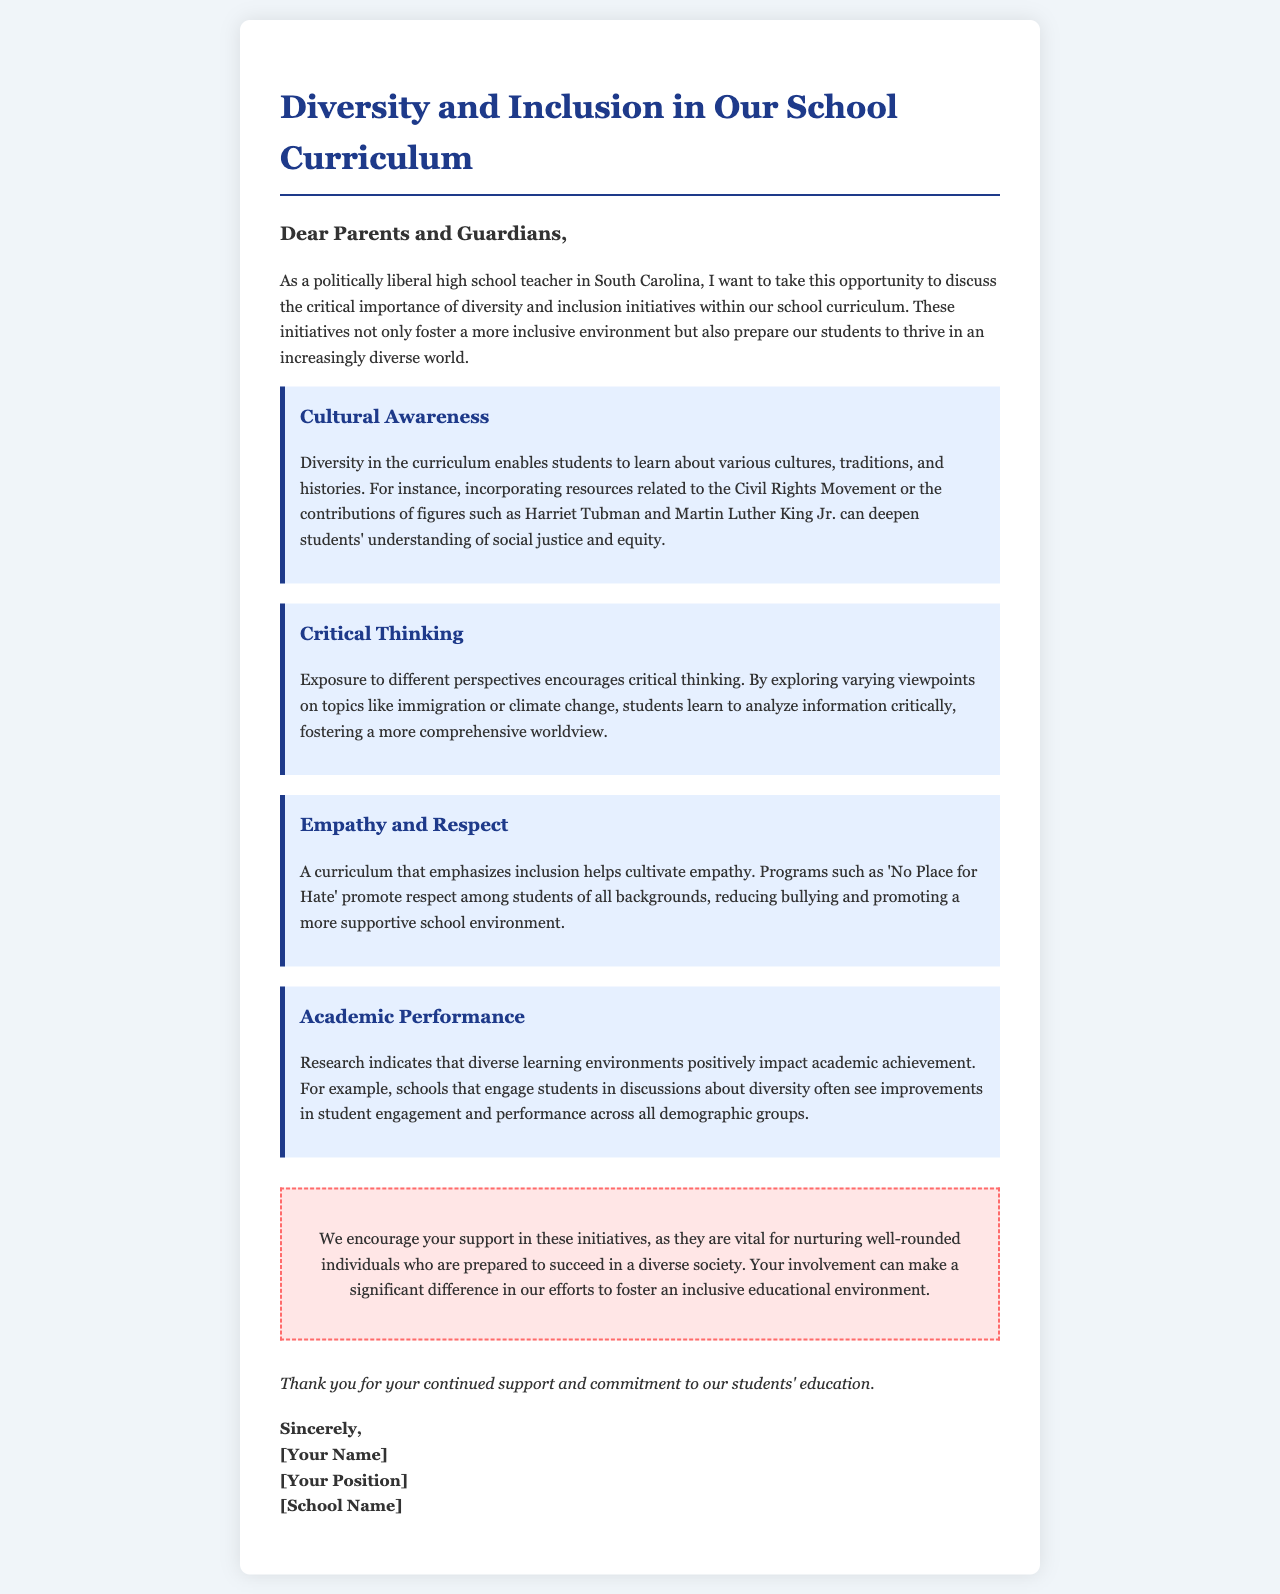What is the title of the letter? The title of the letter indicates the main topic discussed, which is focused on diversity and inclusion in the school curriculum.
Answer: Diversity and Inclusion in Our School Curriculum Who is the letter addressed to? The letter is addressed to the audience that is relevant to the school setting, specifically the caregivers of the students.
Answer: Parents and Guardians What initiative is mentioned that promotes respect? This initiative aims to combat bullying and create a more positive atmosphere within the school.
Answer: No Place for Hate Which historical figures are highlighted for their contributions? The letter mentions notable figures associated with social justice to enrich students' understanding of this pivotal area.
Answer: Harriet Tubman and Martin Luther King Jr What is one of the academic benefits of a diverse learning environment? The letter points out an improvement in an essential educational outcome that can be attributed to diversity.
Answer: Academic achievement How does the letter suggest parents can contribute? The letter emphasizes the role of parents in supporting the initiatives that help create an inclusive environment, making their involvement significant.
Answer: Your involvement What curriculum component does the letter emphasize for critical thinking? The content mentioned aligns with contemporary issues and varying viewpoints, encouraging students to think critically.
Answer: Different perspectives Which program is mentioned in regards to a supportive school environment? The initiative mentioned in the letter is specifically designed to cultivate understanding and respect among students.
Answer: No Place for Hate 